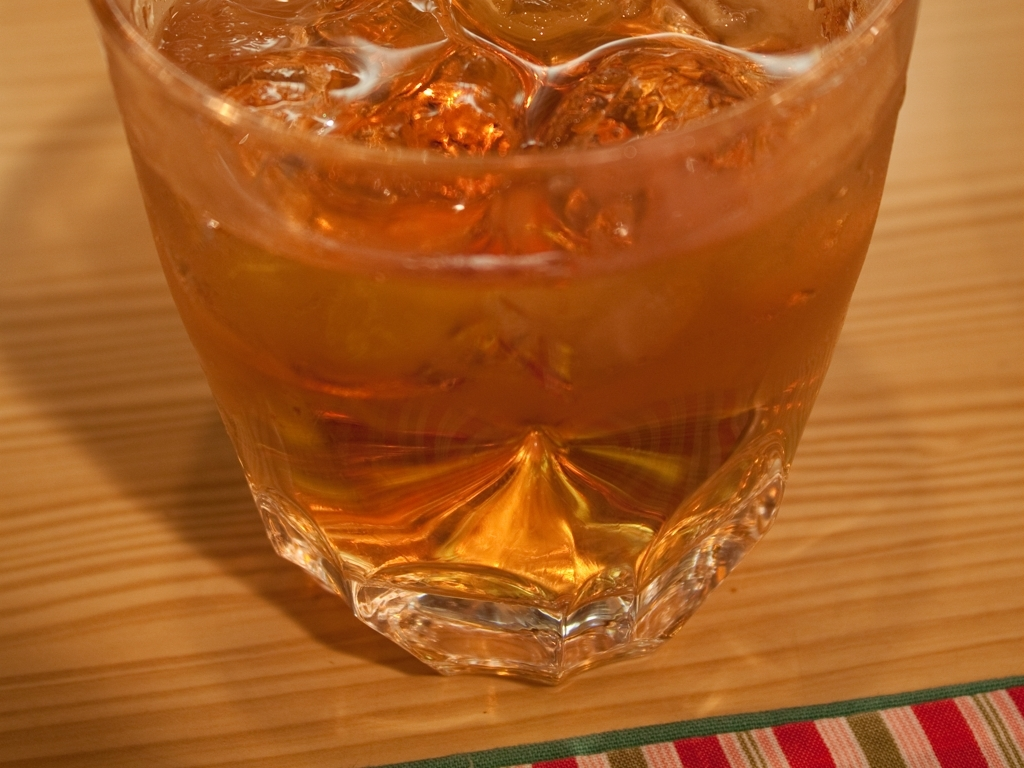Can you guess what kind of liquid might be in the glass? Based on the rich amber color and the presence of ice cubes, it's likely that the glass contains iced tea or a similar beverage. The color is too dark for it to be water and lacks the carbonation bubbles you'd expect to see in a soft drink. 